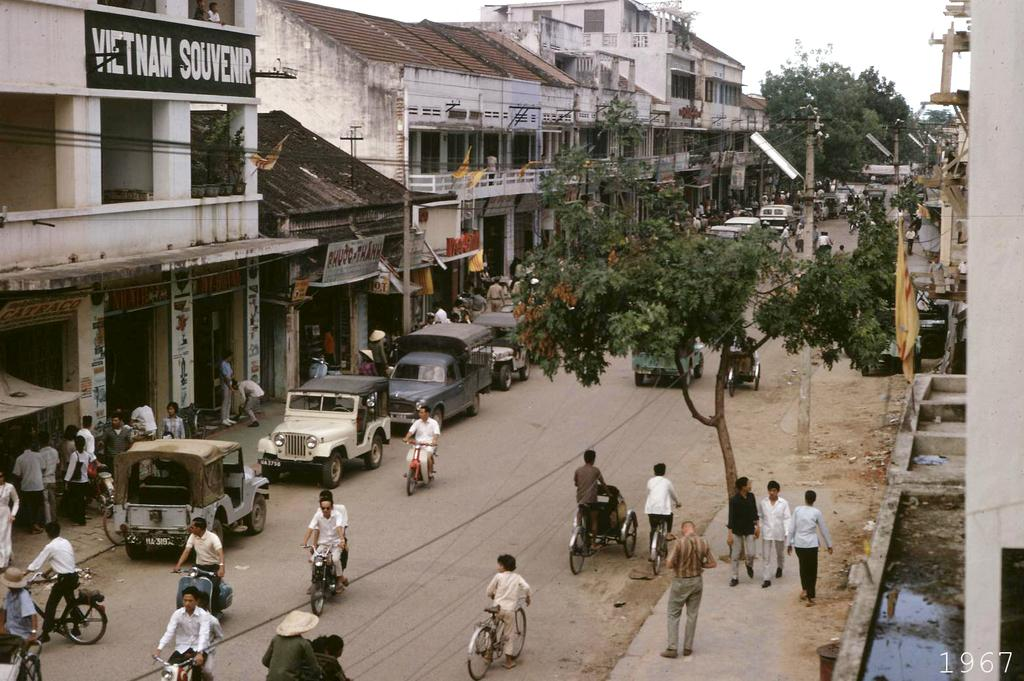<image>
Write a terse but informative summary of the picture. A busy street with people riding bikes in front of the vietnam souvenir building. 